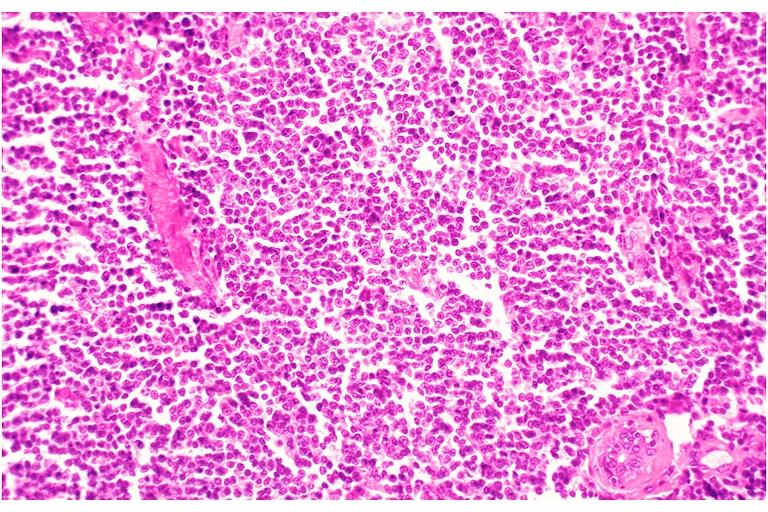s side present?
Answer the question using a single word or phrase. No 